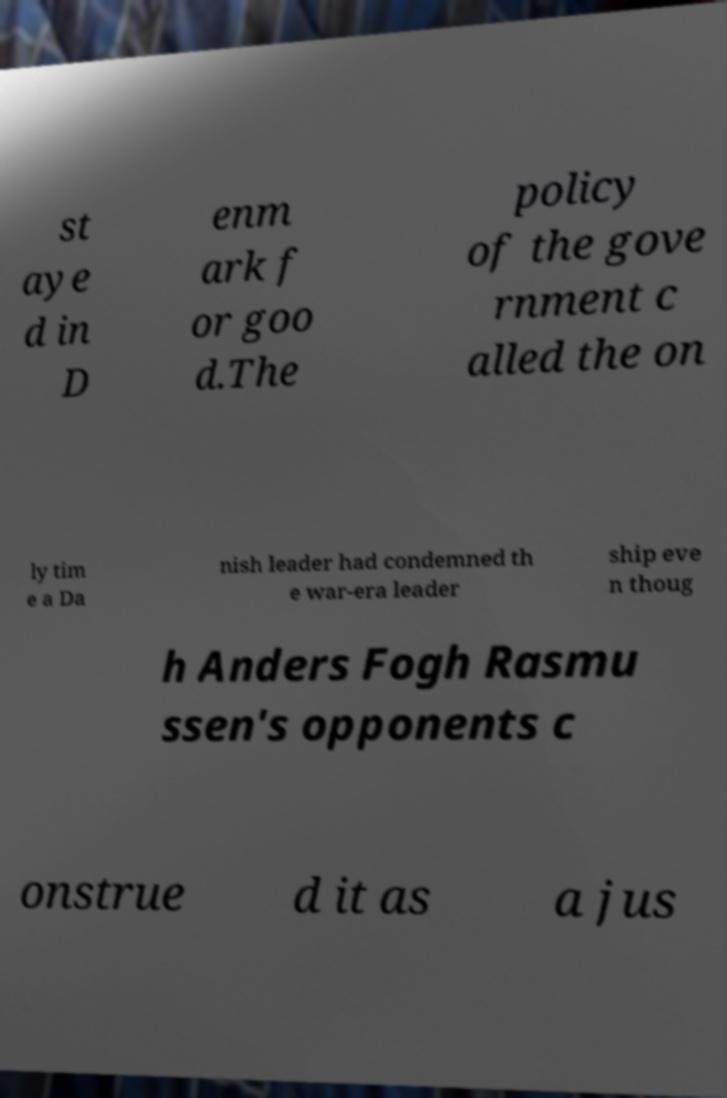I need the written content from this picture converted into text. Can you do that? st aye d in D enm ark f or goo d.The policy of the gove rnment c alled the on ly tim e a Da nish leader had condemned th e war-era leader ship eve n thoug h Anders Fogh Rasmu ssen's opponents c onstrue d it as a jus 